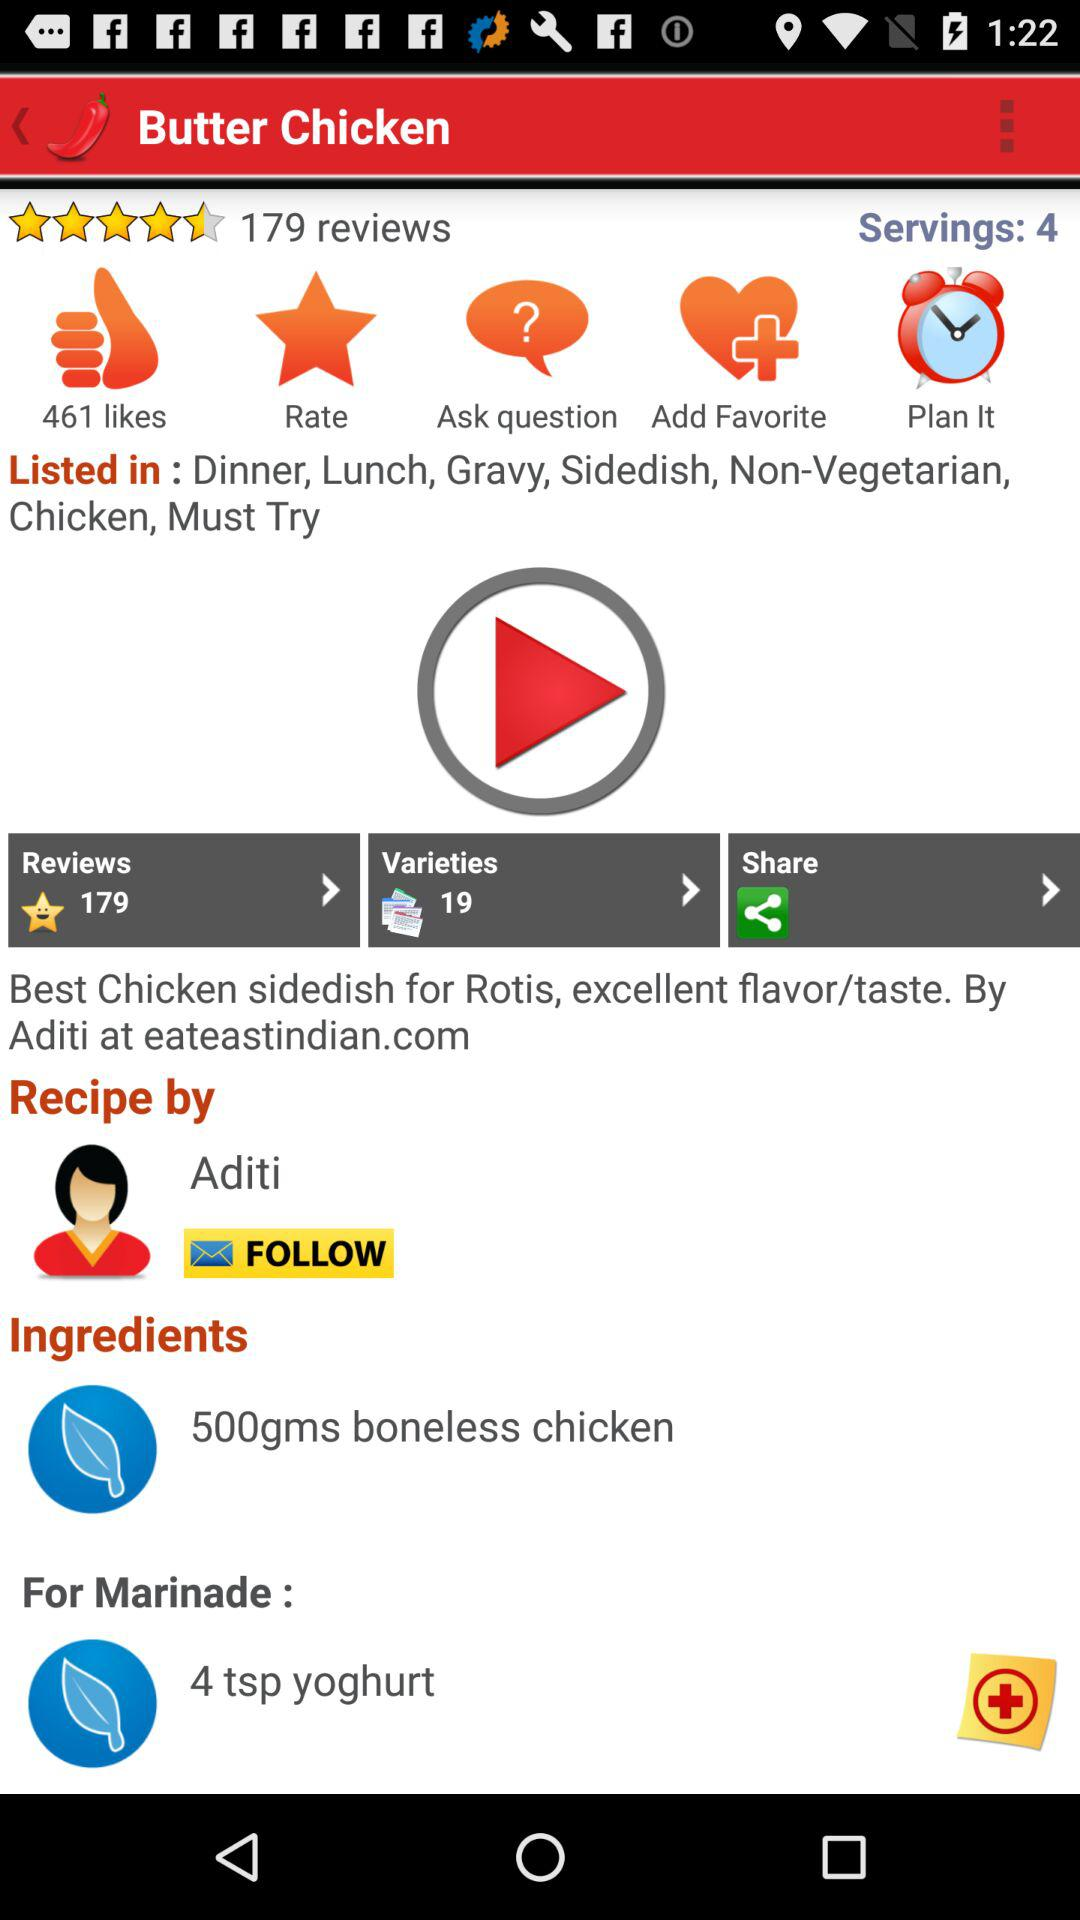How many likes are there? There are 461 likes. 